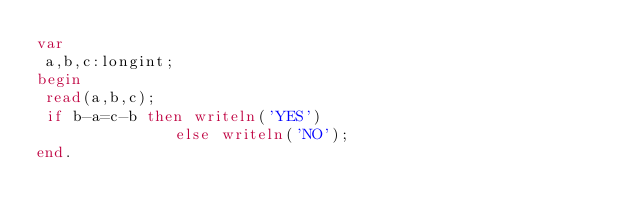Convert code to text. <code><loc_0><loc_0><loc_500><loc_500><_Pascal_>var
 a,b,c:longint;
begin
 read(a,b,c);
 if b-a=c-b then writeln('YES')
               else writeln('NO');
end.</code> 